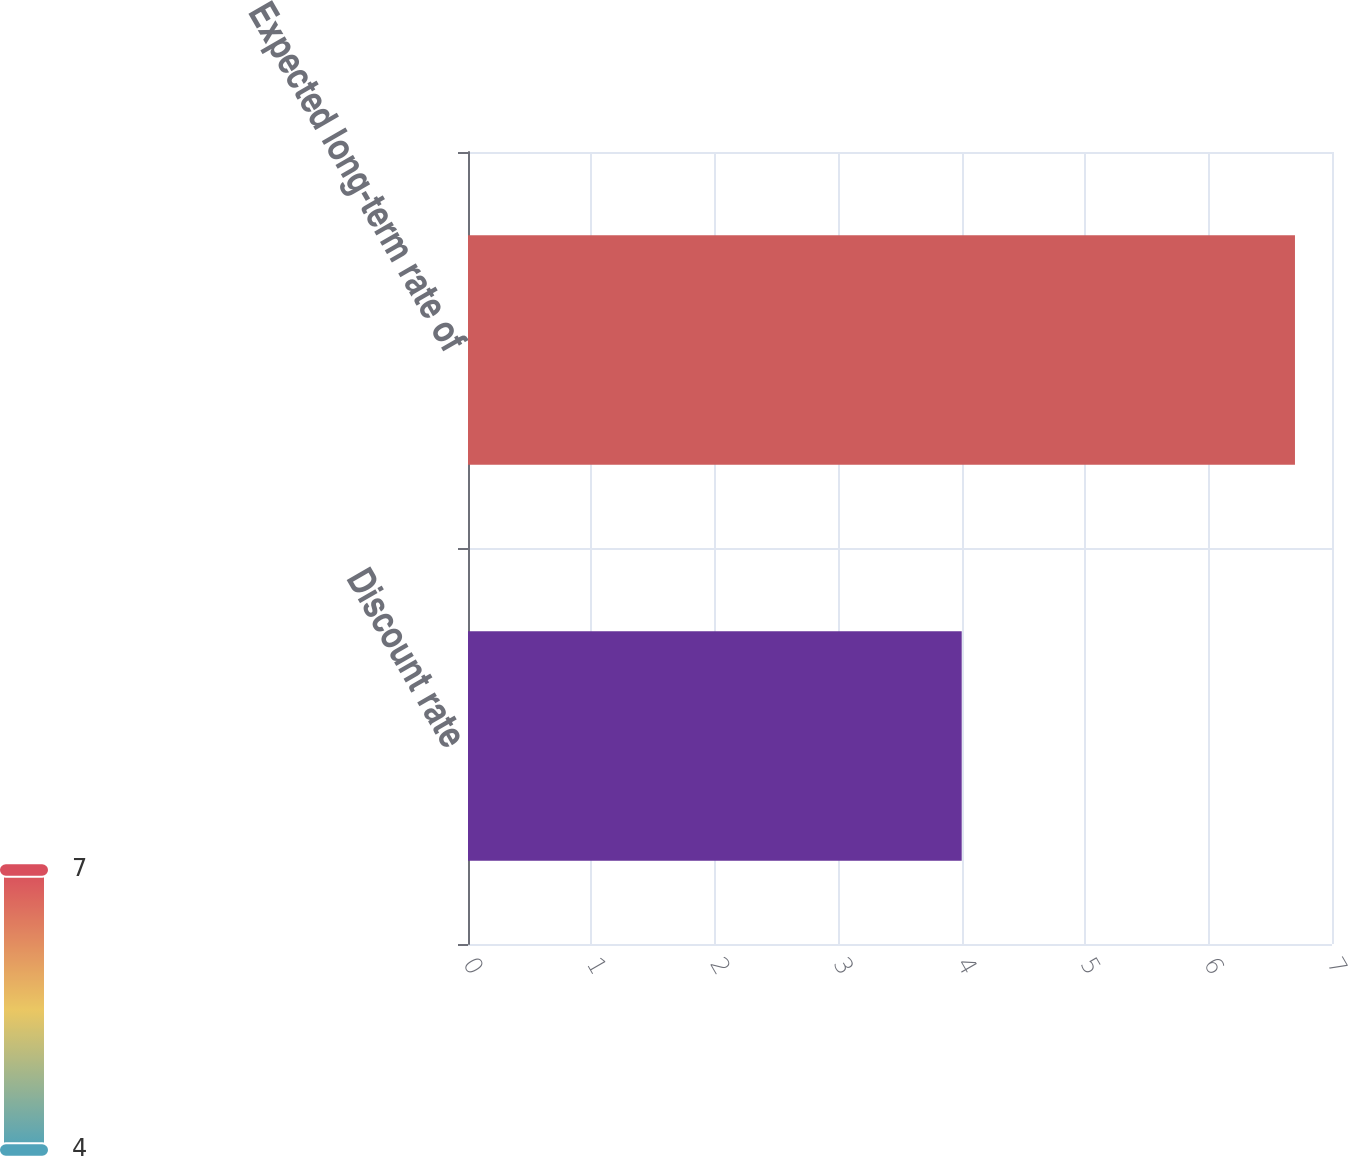<chart> <loc_0><loc_0><loc_500><loc_500><bar_chart><fcel>Discount rate<fcel>Expected long-term rate of<nl><fcel>4<fcel>6.7<nl></chart> 